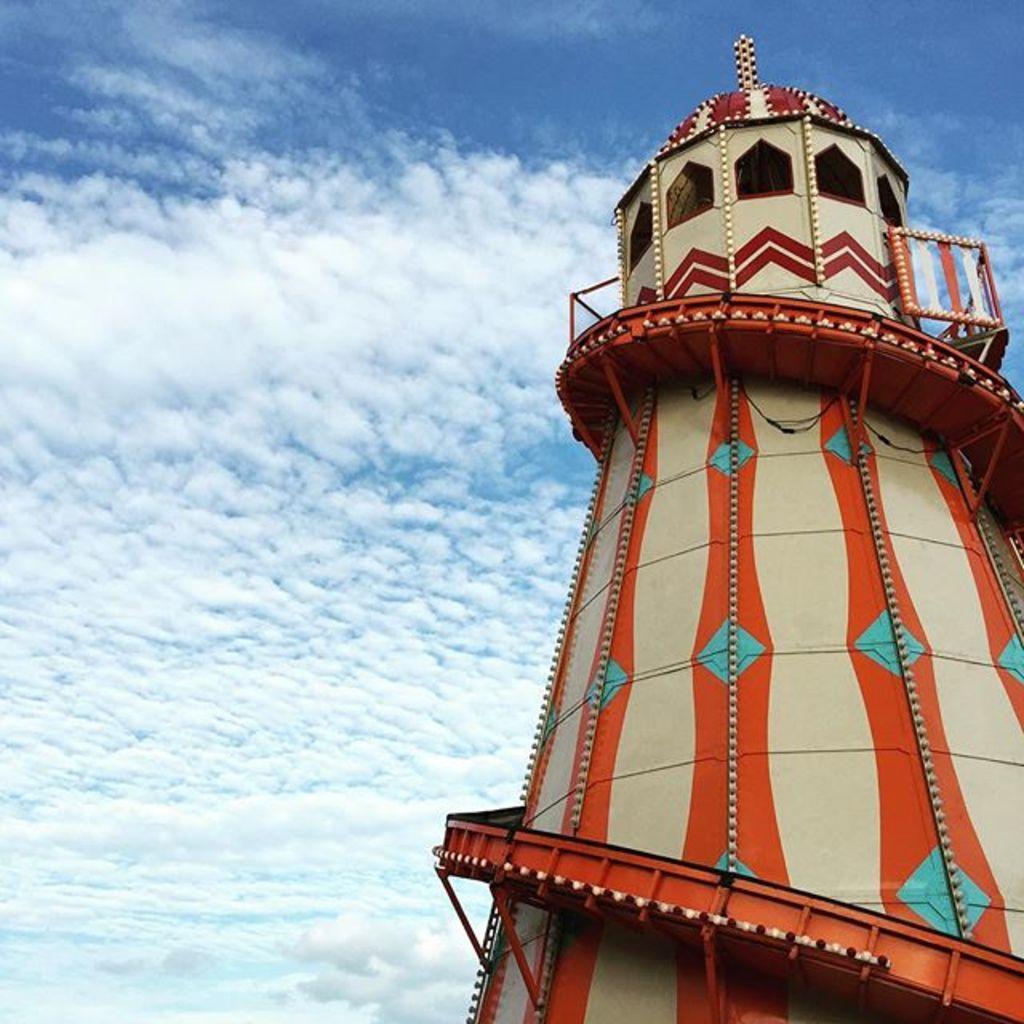Could you give a brief overview of what you see in this image? Here in this picture we can see an observation tower present over there and we can see the sky is fully covered with clouds over there. 